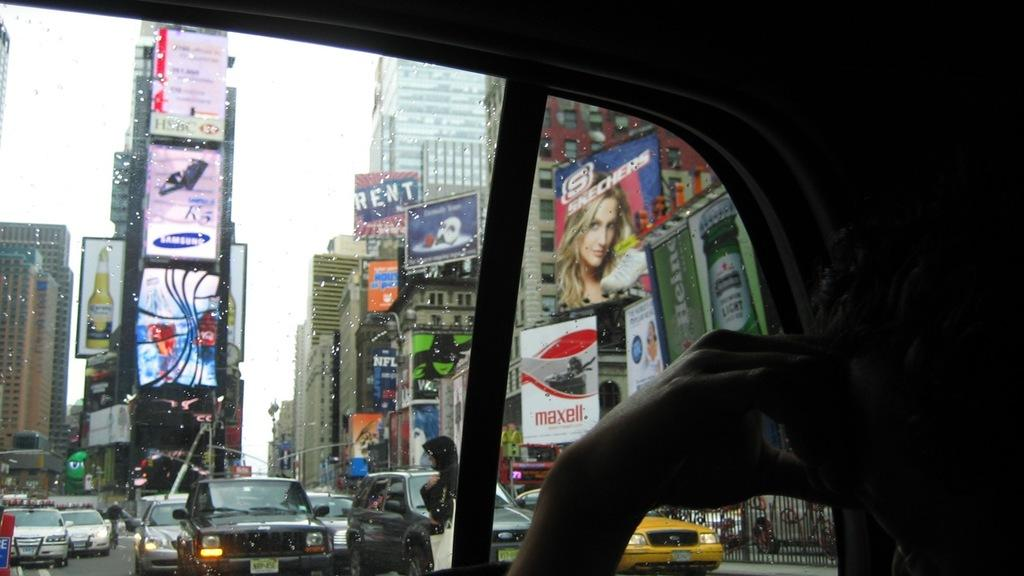<image>
Offer a succinct explanation of the picture presented. advertisements everywhere in the middle of the city in traffic 